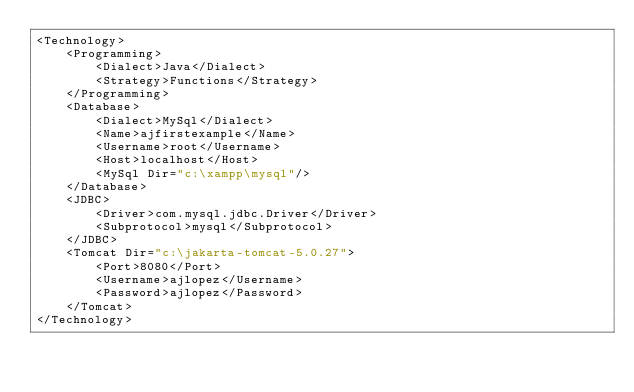<code> <loc_0><loc_0><loc_500><loc_500><_XML_><Technology>
	<Programming>
		<Dialect>Java</Dialect>
		<Strategy>Functions</Strategy>
	</Programming>
	<Database>
		<Dialect>MySql</Dialect>
		<Name>ajfirstexample</Name>
		<Username>root</Username>
		<Host>localhost</Host>
		<MySql Dir="c:\xampp\mysql"/>
	</Database>
	<JDBC>
		<Driver>com.mysql.jdbc.Driver</Driver>
		<Subprotocol>mysql</Subprotocol>
	</JDBC>
	<Tomcat Dir="c:\jakarta-tomcat-5.0.27">
		<Port>8080</Port>
		<Username>ajlopez</Username>
		<Password>ajlopez</Password>
	</Tomcat>
</Technology>
</code> 